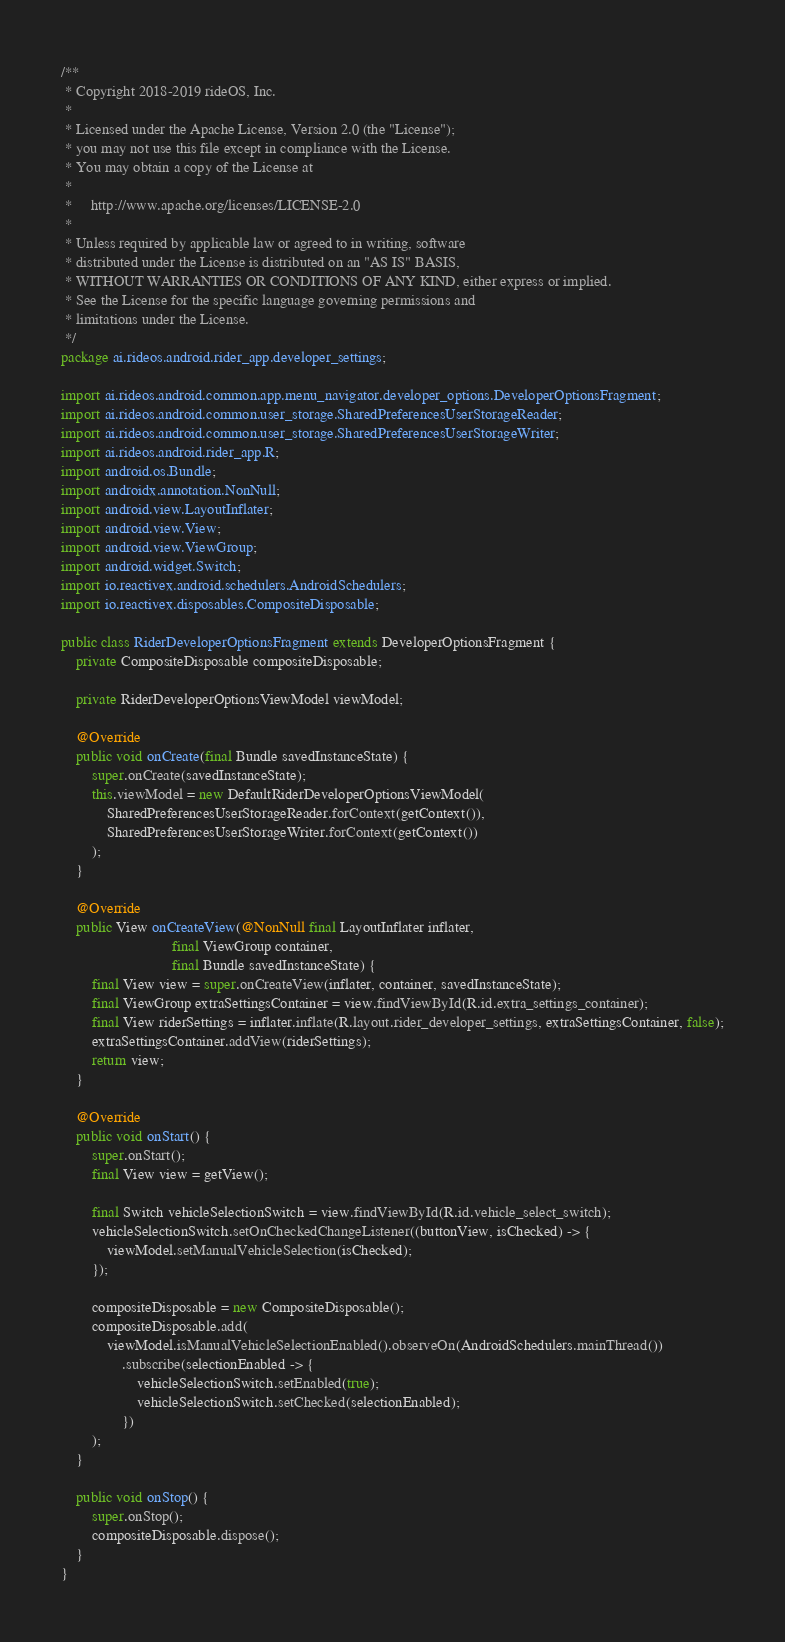Convert code to text. <code><loc_0><loc_0><loc_500><loc_500><_Java_>/**
 * Copyright 2018-2019 rideOS, Inc.
 *
 * Licensed under the Apache License, Version 2.0 (the "License");
 * you may not use this file except in compliance with the License.
 * You may obtain a copy of the License at
 *
 *     http://www.apache.org/licenses/LICENSE-2.0
 *
 * Unless required by applicable law or agreed to in writing, software
 * distributed under the License is distributed on an "AS IS" BASIS,
 * WITHOUT WARRANTIES OR CONDITIONS OF ANY KIND, either express or implied.
 * See the License for the specific language governing permissions and
 * limitations under the License.
 */
package ai.rideos.android.rider_app.developer_settings;

import ai.rideos.android.common.app.menu_navigator.developer_options.DeveloperOptionsFragment;
import ai.rideos.android.common.user_storage.SharedPreferencesUserStorageReader;
import ai.rideos.android.common.user_storage.SharedPreferencesUserStorageWriter;
import ai.rideos.android.rider_app.R;
import android.os.Bundle;
import androidx.annotation.NonNull;
import android.view.LayoutInflater;
import android.view.View;
import android.view.ViewGroup;
import android.widget.Switch;
import io.reactivex.android.schedulers.AndroidSchedulers;
import io.reactivex.disposables.CompositeDisposable;

public class RiderDeveloperOptionsFragment extends DeveloperOptionsFragment {
    private CompositeDisposable compositeDisposable;

    private RiderDeveloperOptionsViewModel viewModel;

    @Override
    public void onCreate(final Bundle savedInstanceState) {
        super.onCreate(savedInstanceState);
        this.viewModel = new DefaultRiderDeveloperOptionsViewModel(
            SharedPreferencesUserStorageReader.forContext(getContext()),
            SharedPreferencesUserStorageWriter.forContext(getContext())
        );
    }

    @Override
    public View onCreateView(@NonNull final LayoutInflater inflater,
                             final ViewGroup container,
                             final Bundle savedInstanceState) {
        final View view = super.onCreateView(inflater, container, savedInstanceState);
        final ViewGroup extraSettingsContainer = view.findViewById(R.id.extra_settings_container);
        final View riderSettings = inflater.inflate(R.layout.rider_developer_settings, extraSettingsContainer, false);
        extraSettingsContainer.addView(riderSettings);
        return view;
    }

    @Override
    public void onStart() {
        super.onStart();
        final View view = getView();

        final Switch vehicleSelectionSwitch = view.findViewById(R.id.vehicle_select_switch);
        vehicleSelectionSwitch.setOnCheckedChangeListener((buttonView, isChecked) -> {
            viewModel.setManualVehicleSelection(isChecked);
        });

        compositeDisposable = new CompositeDisposable();
        compositeDisposable.add(
            viewModel.isManualVehicleSelectionEnabled().observeOn(AndroidSchedulers.mainThread())
                .subscribe(selectionEnabled -> {
                    vehicleSelectionSwitch.setEnabled(true);
                    vehicleSelectionSwitch.setChecked(selectionEnabled);
                })
        );
    }

    public void onStop() {
        super.onStop();
        compositeDisposable.dispose();
    }
}
</code> 